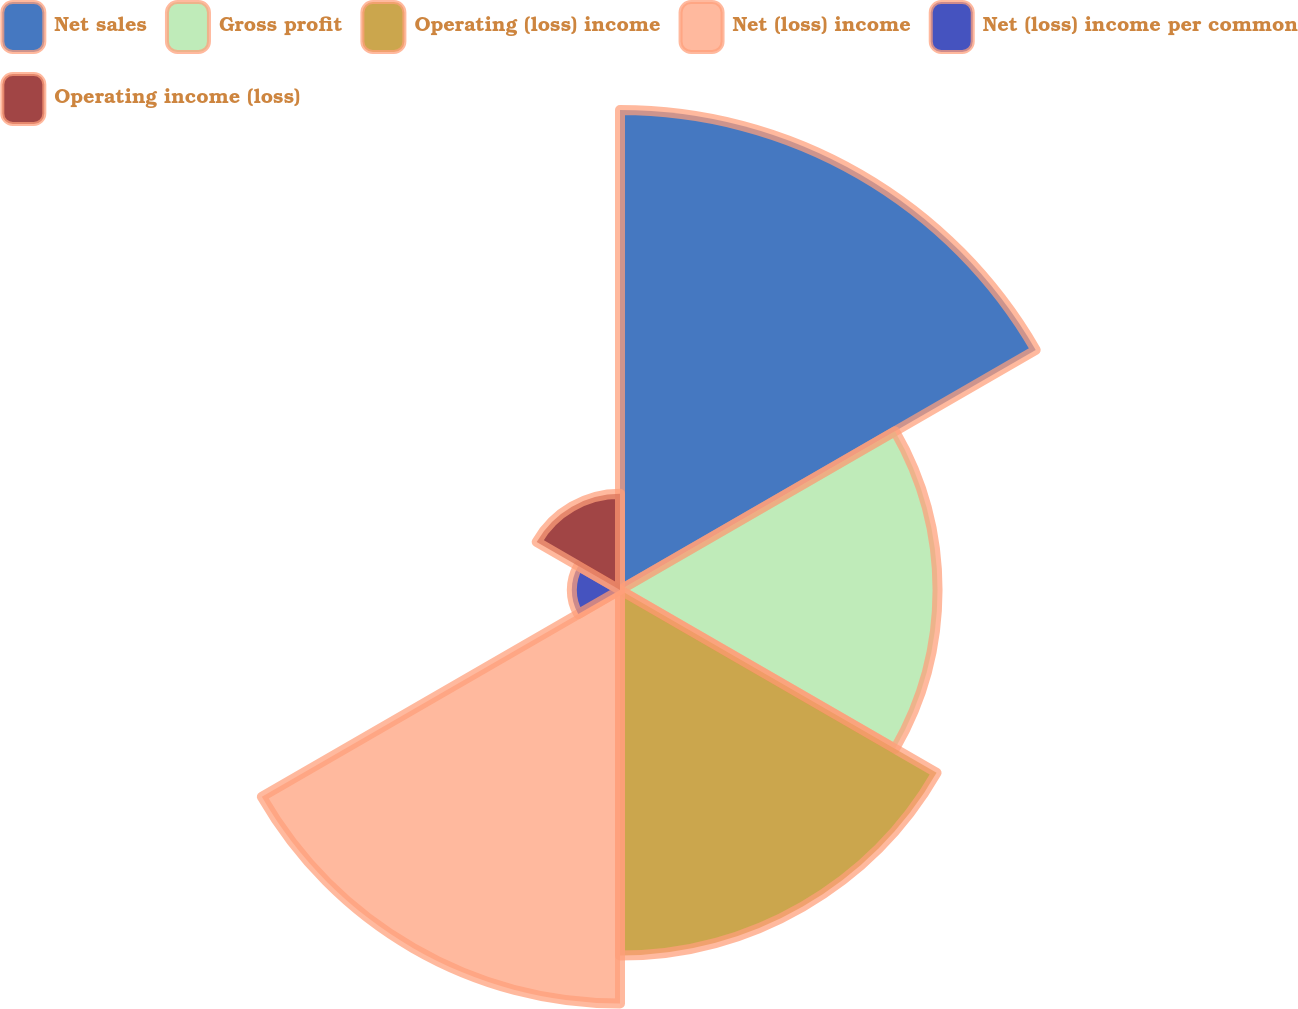Convert chart. <chart><loc_0><loc_0><loc_500><loc_500><pie_chart><fcel>Net sales<fcel>Gross profit<fcel>Operating (loss) income<fcel>Net (loss) income<fcel>Net (loss) income per common<fcel>Operating income (loss)<nl><fcel>27.89%<fcel>18.45%<fcel>21.24%<fcel>24.03%<fcel>2.8%<fcel>5.59%<nl></chart> 